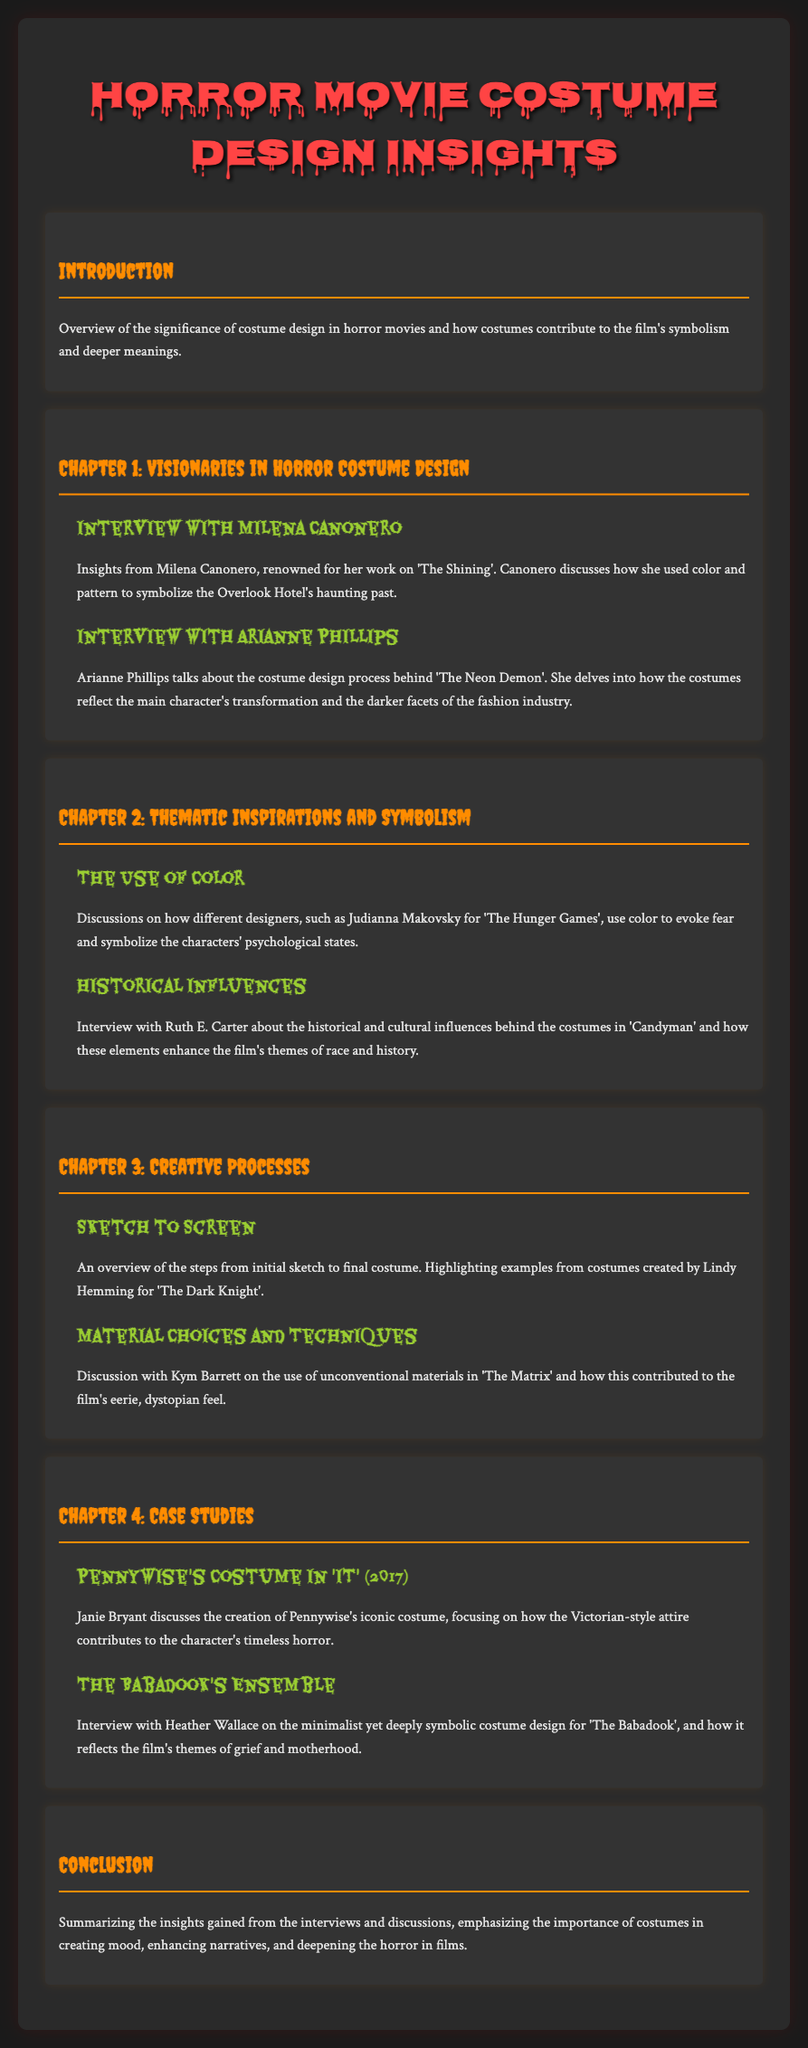What is the main focus of the document? The document discusses insights into horror movie costume design and interviews with top costume designers, highlighting creative processes and thematic inspirations.
Answer: Costume design insights Who designed costumes for 'The Shining'? Milena Canonero is known for her work on the film 'The Shining', discussing color and pattern symbolism.
Answer: Milena Canonero What is a key theme discussed in Arianne Phillips' interview? Arianne Phillips discusses how costumes in 'The Neon Demon' reflect character transformation and darker aspects of the fashion industry.
Answer: Character transformation Which designer is associated with 'The Hunger Games'? Judianna Makovsky is mentioned for her use of color to evoke fear in 'The Hunger Games'.
Answer: Judianna Makovsky What unique materials did Kym Barrett use in ‘The Matrix’? Kym Barrett discussed the use of unconventional materials in ‘The Matrix’ to create an eerie feel.
Answer: Unconventional materials What does Pennywise's costume symbolize? Janie Bryant discusses how Pennywise's Victorian-style attire contributes to the character's timeless horror.
Answer: Timeless horror How did Heather Wallace describe 'The Babadook's costume? Heather Wallace describes the costume for 'The Babadook' as minimalist yet deeply symbolic, reflecting themes of grief and motherhood.
Answer: Minimalist yet deeply symbolic What is the overall conclusion of the document? The conclusion emphasizes the importance of costumes in creating mood, enhancing narratives, and deepening horror in films.
Answer: Importance of costumes 